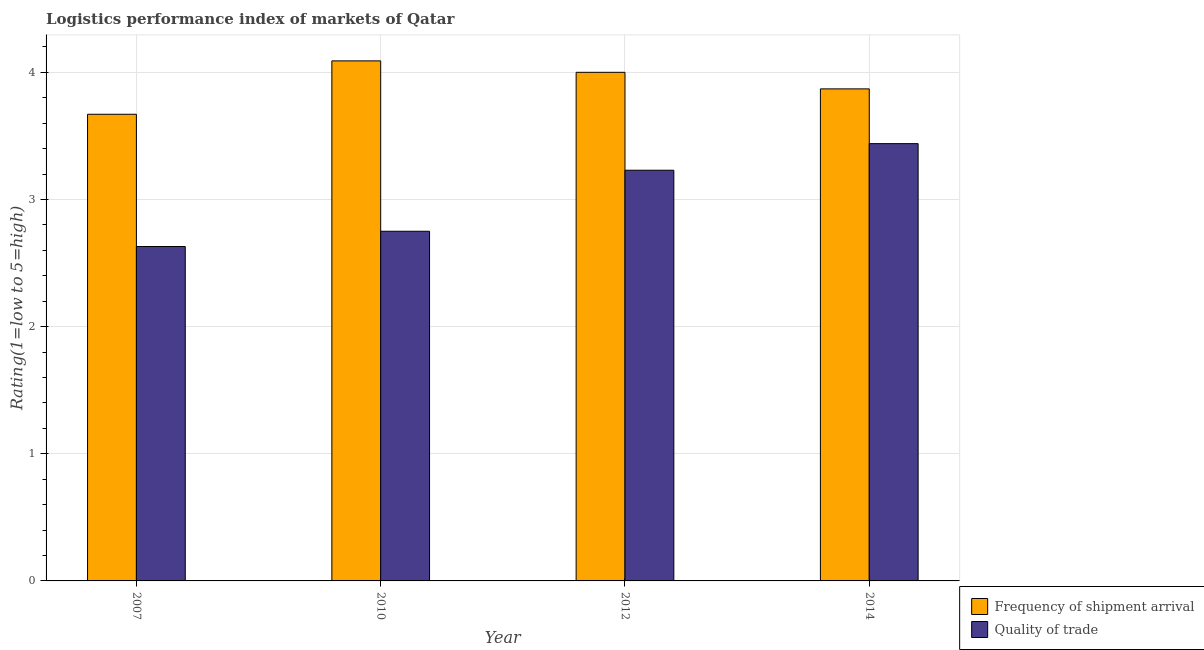How many different coloured bars are there?
Your response must be concise. 2. Are the number of bars per tick equal to the number of legend labels?
Your response must be concise. Yes. Are the number of bars on each tick of the X-axis equal?
Your answer should be compact. Yes. How many bars are there on the 4th tick from the left?
Provide a short and direct response. 2. What is the label of the 4th group of bars from the left?
Provide a short and direct response. 2014. What is the lpi quality of trade in 2012?
Provide a succinct answer. 3.23. Across all years, what is the maximum lpi of frequency of shipment arrival?
Offer a terse response. 4.09. Across all years, what is the minimum lpi of frequency of shipment arrival?
Your answer should be compact. 3.67. In which year was the lpi of frequency of shipment arrival minimum?
Your answer should be compact. 2007. What is the total lpi of frequency of shipment arrival in the graph?
Offer a very short reply. 15.63. What is the difference between the lpi of frequency of shipment arrival in 2012 and that in 2014?
Offer a very short reply. 0.13. What is the difference between the lpi of frequency of shipment arrival in 2010 and the lpi quality of trade in 2014?
Make the answer very short. 0.22. What is the average lpi quality of trade per year?
Your response must be concise. 3.01. In the year 2010, what is the difference between the lpi of frequency of shipment arrival and lpi quality of trade?
Offer a very short reply. 0. In how many years, is the lpi quality of trade greater than 1.4?
Make the answer very short. 4. What is the ratio of the lpi quality of trade in 2007 to that in 2012?
Offer a terse response. 0.81. Is the lpi quality of trade in 2007 less than that in 2012?
Your response must be concise. Yes. What is the difference between the highest and the second highest lpi of frequency of shipment arrival?
Keep it short and to the point. 0.09. What is the difference between the highest and the lowest lpi of frequency of shipment arrival?
Provide a succinct answer. 0.42. In how many years, is the lpi of frequency of shipment arrival greater than the average lpi of frequency of shipment arrival taken over all years?
Offer a very short reply. 2. Is the sum of the lpi quality of trade in 2012 and 2014 greater than the maximum lpi of frequency of shipment arrival across all years?
Make the answer very short. Yes. What does the 1st bar from the left in 2012 represents?
Your answer should be very brief. Frequency of shipment arrival. What does the 2nd bar from the right in 2010 represents?
Your answer should be very brief. Frequency of shipment arrival. Are all the bars in the graph horizontal?
Your answer should be very brief. No. How many years are there in the graph?
Your answer should be compact. 4. What is the difference between two consecutive major ticks on the Y-axis?
Your answer should be very brief. 1. Are the values on the major ticks of Y-axis written in scientific E-notation?
Keep it short and to the point. No. Does the graph contain any zero values?
Offer a very short reply. No. Where does the legend appear in the graph?
Your answer should be very brief. Bottom right. What is the title of the graph?
Keep it short and to the point. Logistics performance index of markets of Qatar. Does "Female" appear as one of the legend labels in the graph?
Provide a short and direct response. No. What is the label or title of the X-axis?
Offer a very short reply. Year. What is the label or title of the Y-axis?
Make the answer very short. Rating(1=low to 5=high). What is the Rating(1=low to 5=high) in Frequency of shipment arrival in 2007?
Your answer should be very brief. 3.67. What is the Rating(1=low to 5=high) of Quality of trade in 2007?
Your answer should be very brief. 2.63. What is the Rating(1=low to 5=high) in Frequency of shipment arrival in 2010?
Your answer should be very brief. 4.09. What is the Rating(1=low to 5=high) of Quality of trade in 2010?
Make the answer very short. 2.75. What is the Rating(1=low to 5=high) of Frequency of shipment arrival in 2012?
Offer a very short reply. 4. What is the Rating(1=low to 5=high) in Quality of trade in 2012?
Your response must be concise. 3.23. What is the Rating(1=low to 5=high) in Frequency of shipment arrival in 2014?
Your response must be concise. 3.87. What is the Rating(1=low to 5=high) in Quality of trade in 2014?
Your response must be concise. 3.44. Across all years, what is the maximum Rating(1=low to 5=high) in Frequency of shipment arrival?
Offer a terse response. 4.09. Across all years, what is the maximum Rating(1=low to 5=high) of Quality of trade?
Your answer should be very brief. 3.44. Across all years, what is the minimum Rating(1=low to 5=high) in Frequency of shipment arrival?
Your answer should be compact. 3.67. Across all years, what is the minimum Rating(1=low to 5=high) of Quality of trade?
Offer a very short reply. 2.63. What is the total Rating(1=low to 5=high) in Frequency of shipment arrival in the graph?
Your answer should be compact. 15.63. What is the total Rating(1=low to 5=high) in Quality of trade in the graph?
Offer a very short reply. 12.05. What is the difference between the Rating(1=low to 5=high) of Frequency of shipment arrival in 2007 and that in 2010?
Keep it short and to the point. -0.42. What is the difference between the Rating(1=low to 5=high) of Quality of trade in 2007 and that in 2010?
Ensure brevity in your answer.  -0.12. What is the difference between the Rating(1=low to 5=high) in Frequency of shipment arrival in 2007 and that in 2012?
Provide a short and direct response. -0.33. What is the difference between the Rating(1=low to 5=high) in Frequency of shipment arrival in 2007 and that in 2014?
Your answer should be very brief. -0.2. What is the difference between the Rating(1=low to 5=high) in Quality of trade in 2007 and that in 2014?
Keep it short and to the point. -0.81. What is the difference between the Rating(1=low to 5=high) of Frequency of shipment arrival in 2010 and that in 2012?
Provide a succinct answer. 0.09. What is the difference between the Rating(1=low to 5=high) of Quality of trade in 2010 and that in 2012?
Offer a very short reply. -0.48. What is the difference between the Rating(1=low to 5=high) of Frequency of shipment arrival in 2010 and that in 2014?
Your answer should be compact. 0.22. What is the difference between the Rating(1=low to 5=high) in Quality of trade in 2010 and that in 2014?
Provide a short and direct response. -0.69. What is the difference between the Rating(1=low to 5=high) in Frequency of shipment arrival in 2012 and that in 2014?
Make the answer very short. 0.13. What is the difference between the Rating(1=low to 5=high) in Quality of trade in 2012 and that in 2014?
Offer a very short reply. -0.21. What is the difference between the Rating(1=low to 5=high) of Frequency of shipment arrival in 2007 and the Rating(1=low to 5=high) of Quality of trade in 2010?
Keep it short and to the point. 0.92. What is the difference between the Rating(1=low to 5=high) of Frequency of shipment arrival in 2007 and the Rating(1=low to 5=high) of Quality of trade in 2012?
Your answer should be very brief. 0.44. What is the difference between the Rating(1=low to 5=high) in Frequency of shipment arrival in 2007 and the Rating(1=low to 5=high) in Quality of trade in 2014?
Offer a terse response. 0.23. What is the difference between the Rating(1=low to 5=high) in Frequency of shipment arrival in 2010 and the Rating(1=low to 5=high) in Quality of trade in 2012?
Make the answer very short. 0.86. What is the difference between the Rating(1=low to 5=high) in Frequency of shipment arrival in 2010 and the Rating(1=low to 5=high) in Quality of trade in 2014?
Provide a succinct answer. 0.65. What is the difference between the Rating(1=low to 5=high) of Frequency of shipment arrival in 2012 and the Rating(1=low to 5=high) of Quality of trade in 2014?
Ensure brevity in your answer.  0.56. What is the average Rating(1=low to 5=high) in Frequency of shipment arrival per year?
Give a very brief answer. 3.91. What is the average Rating(1=low to 5=high) in Quality of trade per year?
Ensure brevity in your answer.  3.01. In the year 2007, what is the difference between the Rating(1=low to 5=high) of Frequency of shipment arrival and Rating(1=low to 5=high) of Quality of trade?
Offer a very short reply. 1.04. In the year 2010, what is the difference between the Rating(1=low to 5=high) of Frequency of shipment arrival and Rating(1=low to 5=high) of Quality of trade?
Your response must be concise. 1.34. In the year 2012, what is the difference between the Rating(1=low to 5=high) of Frequency of shipment arrival and Rating(1=low to 5=high) of Quality of trade?
Keep it short and to the point. 0.77. In the year 2014, what is the difference between the Rating(1=low to 5=high) in Frequency of shipment arrival and Rating(1=low to 5=high) in Quality of trade?
Ensure brevity in your answer.  0.43. What is the ratio of the Rating(1=low to 5=high) in Frequency of shipment arrival in 2007 to that in 2010?
Your answer should be very brief. 0.9. What is the ratio of the Rating(1=low to 5=high) of Quality of trade in 2007 to that in 2010?
Offer a very short reply. 0.96. What is the ratio of the Rating(1=low to 5=high) of Frequency of shipment arrival in 2007 to that in 2012?
Provide a succinct answer. 0.92. What is the ratio of the Rating(1=low to 5=high) in Quality of trade in 2007 to that in 2012?
Make the answer very short. 0.81. What is the ratio of the Rating(1=low to 5=high) of Frequency of shipment arrival in 2007 to that in 2014?
Offer a very short reply. 0.95. What is the ratio of the Rating(1=low to 5=high) of Quality of trade in 2007 to that in 2014?
Ensure brevity in your answer.  0.76. What is the ratio of the Rating(1=low to 5=high) of Frequency of shipment arrival in 2010 to that in 2012?
Keep it short and to the point. 1.02. What is the ratio of the Rating(1=low to 5=high) in Quality of trade in 2010 to that in 2012?
Make the answer very short. 0.85. What is the ratio of the Rating(1=low to 5=high) of Frequency of shipment arrival in 2010 to that in 2014?
Offer a terse response. 1.06. What is the ratio of the Rating(1=low to 5=high) in Quality of trade in 2010 to that in 2014?
Provide a succinct answer. 0.8. What is the ratio of the Rating(1=low to 5=high) in Frequency of shipment arrival in 2012 to that in 2014?
Provide a short and direct response. 1.03. What is the ratio of the Rating(1=low to 5=high) in Quality of trade in 2012 to that in 2014?
Provide a short and direct response. 0.94. What is the difference between the highest and the second highest Rating(1=low to 5=high) of Frequency of shipment arrival?
Provide a short and direct response. 0.09. What is the difference between the highest and the second highest Rating(1=low to 5=high) in Quality of trade?
Your answer should be compact. 0.21. What is the difference between the highest and the lowest Rating(1=low to 5=high) in Frequency of shipment arrival?
Your response must be concise. 0.42. What is the difference between the highest and the lowest Rating(1=low to 5=high) of Quality of trade?
Provide a short and direct response. 0.81. 